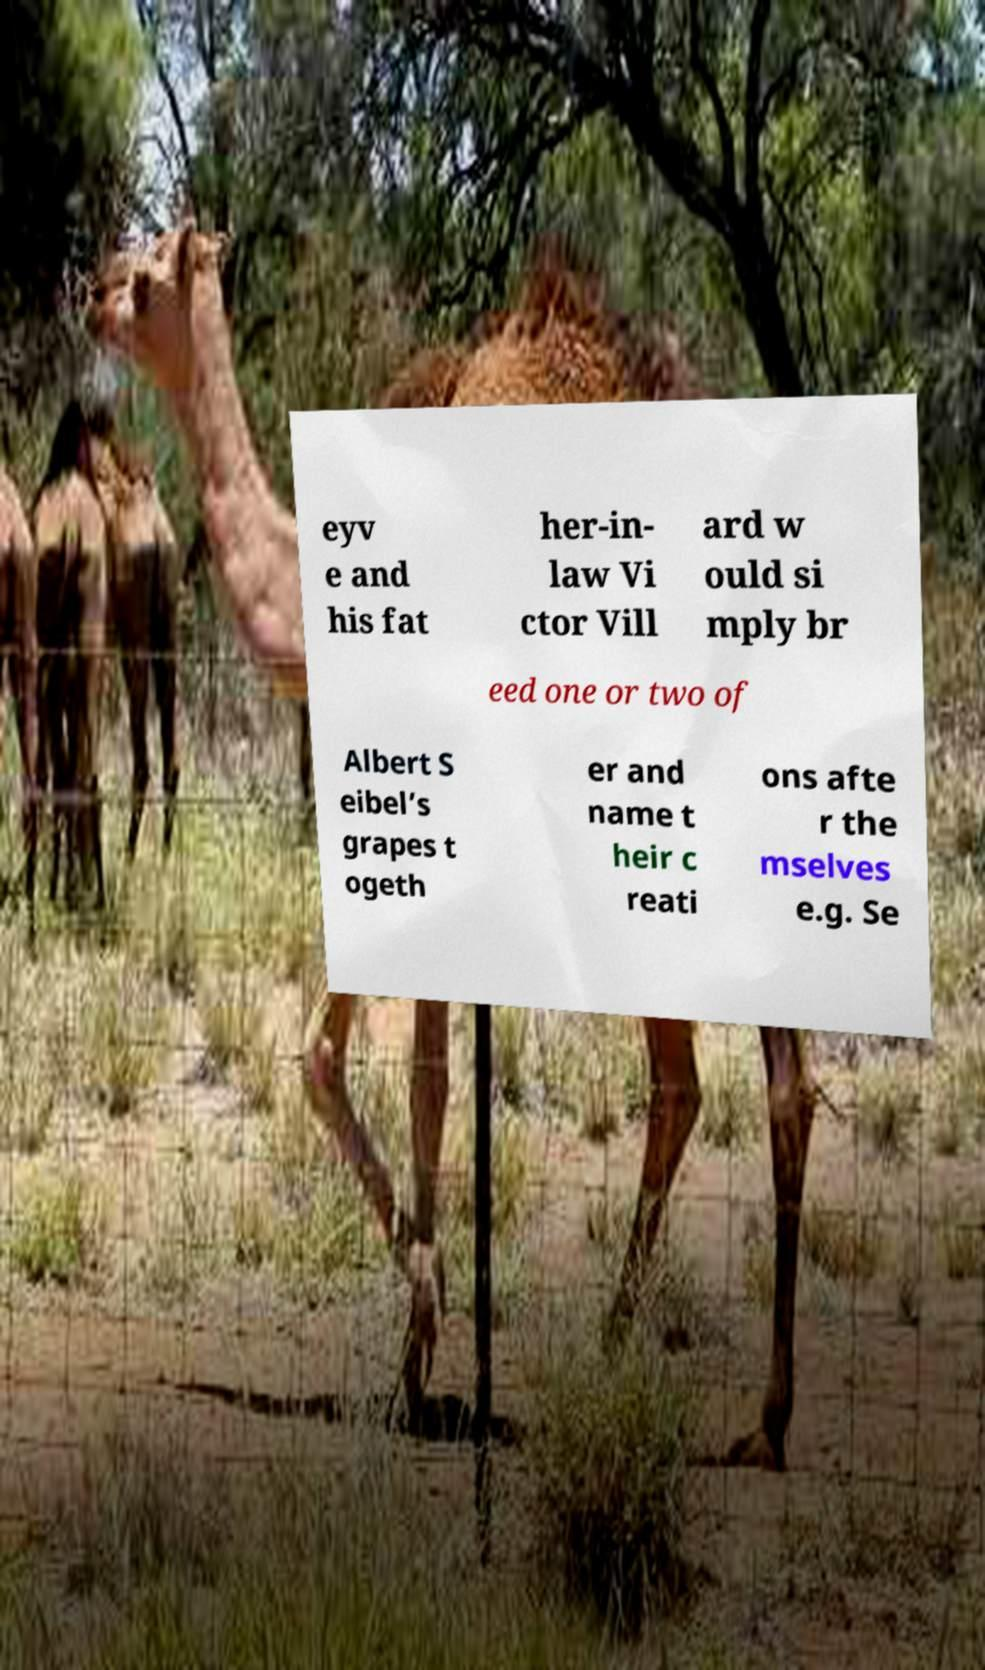For documentation purposes, I need the text within this image transcribed. Could you provide that? eyv e and his fat her-in- law Vi ctor Vill ard w ould si mply br eed one or two of Albert S eibel’s grapes t ogeth er and name t heir c reati ons afte r the mselves e.g. Se 